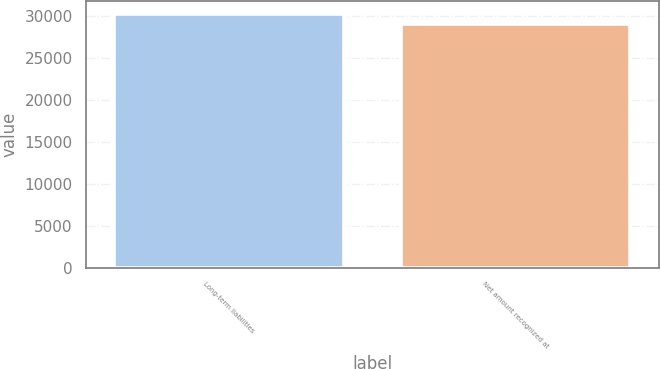<chart> <loc_0><loc_0><loc_500><loc_500><bar_chart><fcel>Long-term liabilities<fcel>Net amount recognized at<nl><fcel>30230<fcel>28998<nl></chart> 